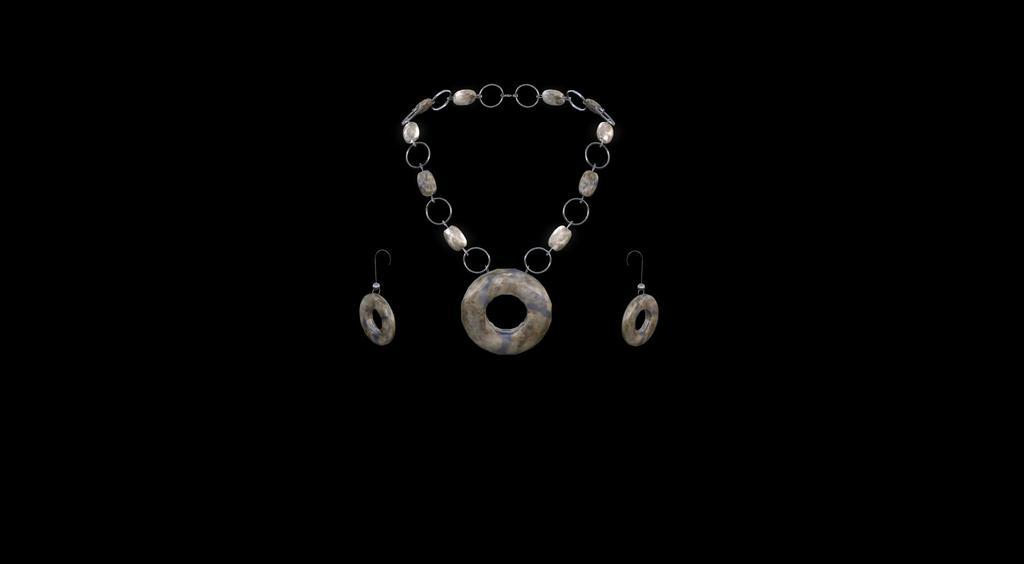What type of object can be seen in the image? There is a chain in the image. What type of accessory is also visible in the image? There are earrings in the image. How does the chain help with the growth of plants in the image? There are no plants present in the image, and the chain is not associated with plant growth. 